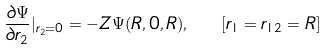<formula> <loc_0><loc_0><loc_500><loc_500>\frac { \partial \Psi } { \partial r _ { 2 } } | _ { r _ { 2 } = 0 } = - Z \Psi ( R , 0 , R ) , \ \ [ r _ { 1 } = r _ { 1 2 } = R ]</formula> 